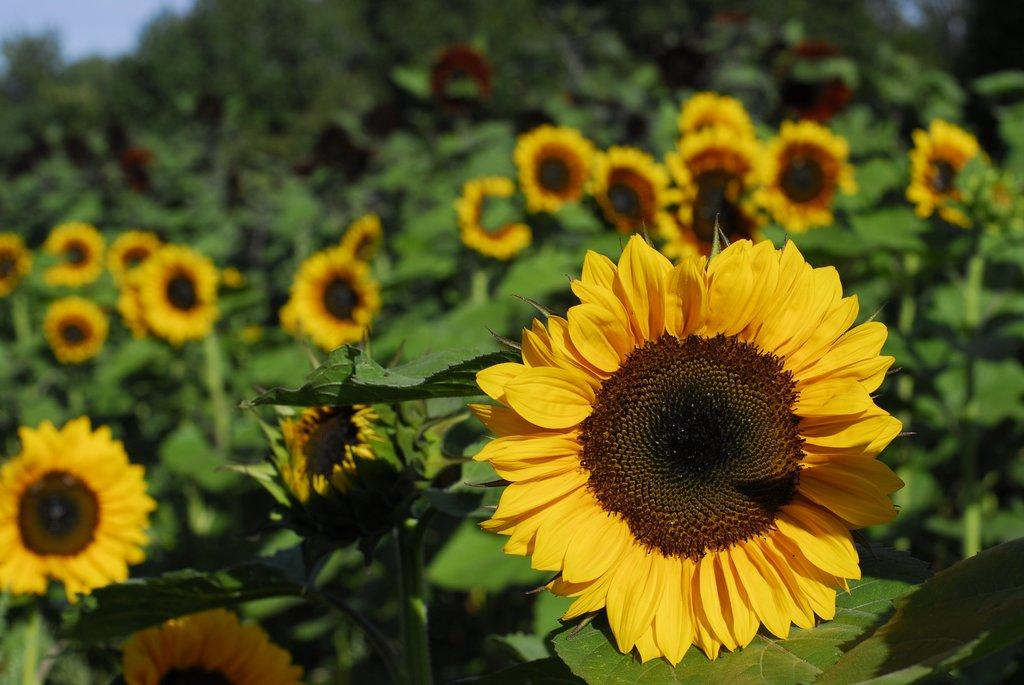What type of plants can be seen in the image? There are plants with flowers in the image. What can be seen in the background of the image? There are trees and the sky visible in the background of the image. How does the background appear in the image? The background appears blurry. How many pizzas are being served to the deer in the image? There are no pizzas or deer present in the image. 